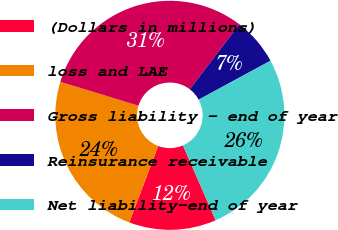Convert chart to OTSL. <chart><loc_0><loc_0><loc_500><loc_500><pie_chart><fcel>(Dollars in millions)<fcel>loss and LAE<fcel>Gross liability - end of year<fcel>Reinsurance receivable<fcel>Net liability-end of year<nl><fcel>12.31%<fcel>23.96%<fcel>30.66%<fcel>6.7%<fcel>26.36%<nl></chart> 